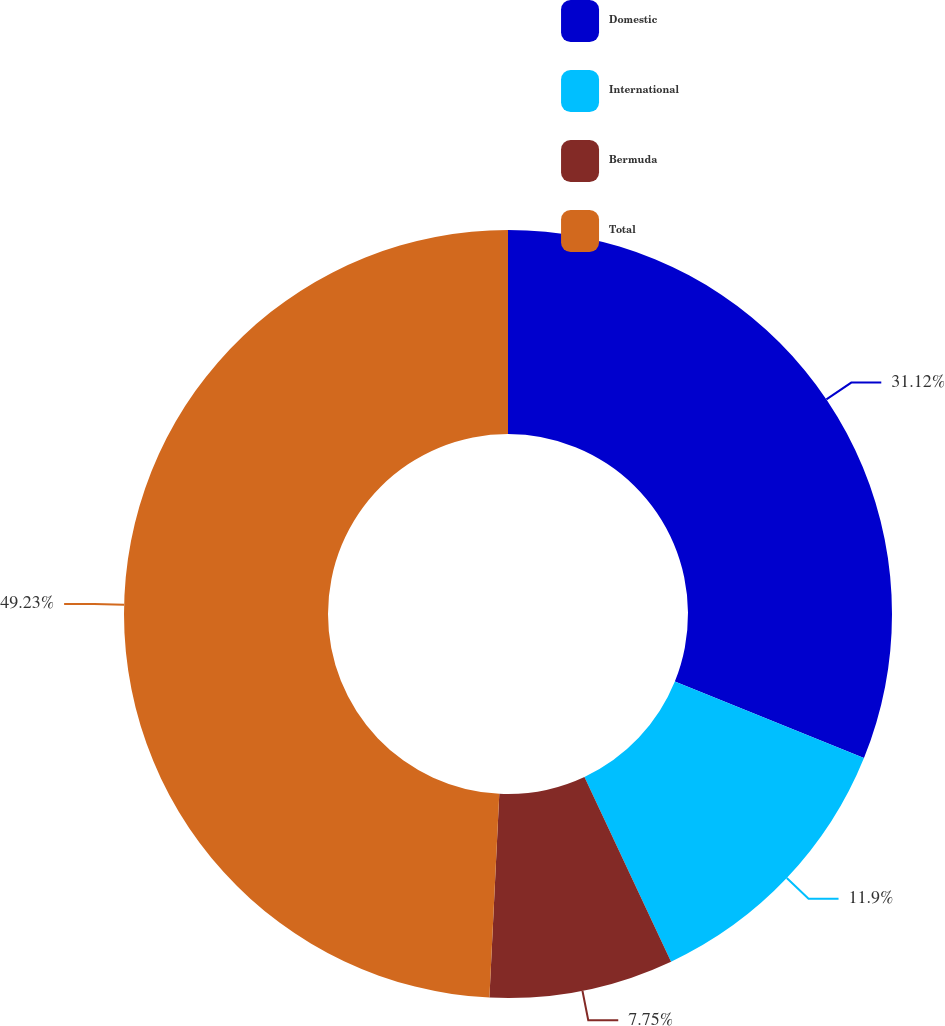Convert chart to OTSL. <chart><loc_0><loc_0><loc_500><loc_500><pie_chart><fcel>Domestic<fcel>International<fcel>Bermuda<fcel>Total<nl><fcel>31.12%<fcel>11.9%<fcel>7.75%<fcel>49.23%<nl></chart> 